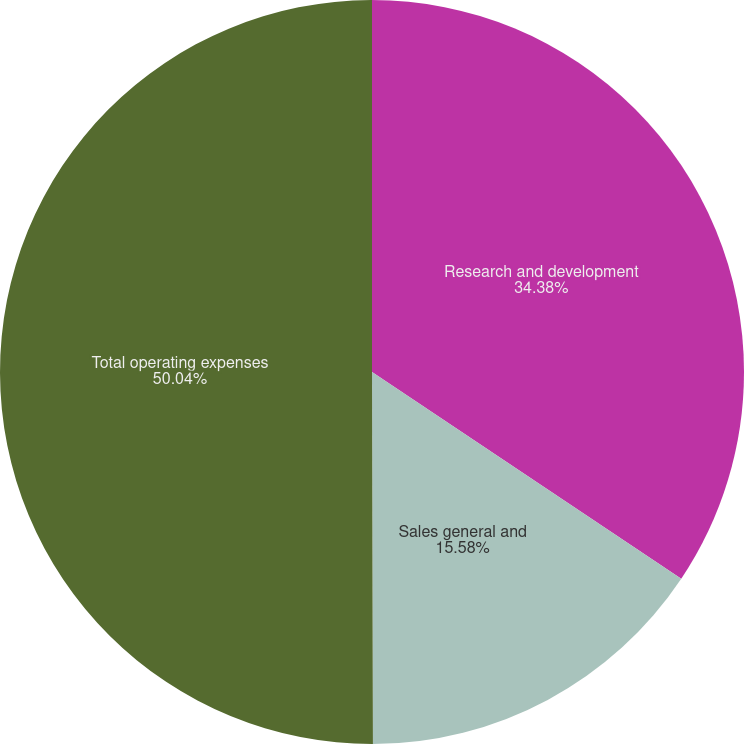Convert chart to OTSL. <chart><loc_0><loc_0><loc_500><loc_500><pie_chart><fcel>Research and development<fcel>Sales general and<fcel>Total operating expenses<nl><fcel>34.38%<fcel>15.58%<fcel>50.04%<nl></chart> 